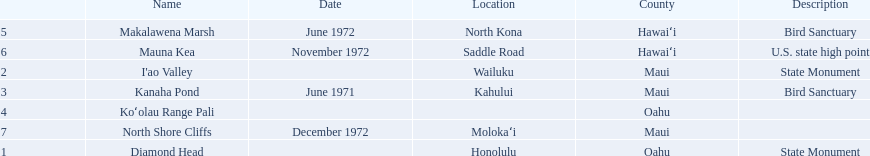What is the name of the only landmark that is also a u.s. state high point? Mauna Kea. 